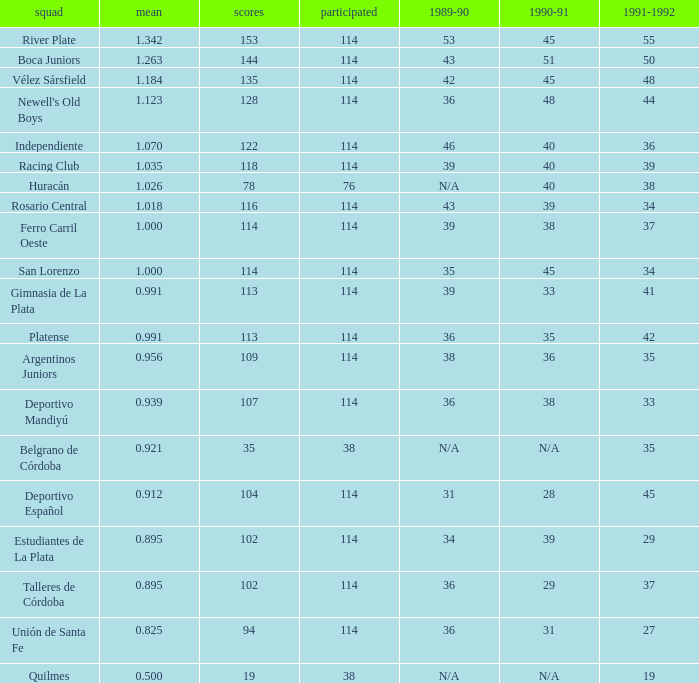How much 1991-1992 has a Team of gimnasia de la plata, and more than 113 points? 0.0. 